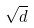<formula> <loc_0><loc_0><loc_500><loc_500>\sqrt { d }</formula> 